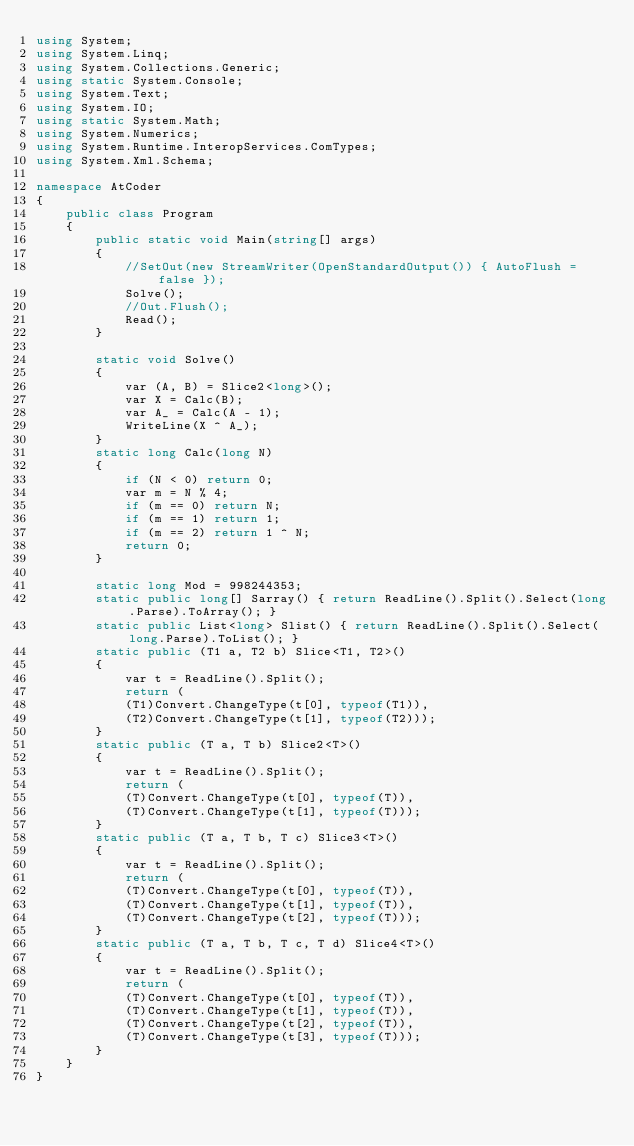<code> <loc_0><loc_0><loc_500><loc_500><_C#_>using System;
using System.Linq;
using System.Collections.Generic;
using static System.Console;
using System.Text;
using System.IO;
using static System.Math;
using System.Numerics;
using System.Runtime.InteropServices.ComTypes;
using System.Xml.Schema;

namespace AtCoder
{
    public class Program
    {
        public static void Main(string[] args)
        {
            //SetOut(new StreamWriter(OpenStandardOutput()) { AutoFlush = false });
            Solve();
            //Out.Flush();
            Read();
        }

        static void Solve()
        {
            var (A, B) = Slice2<long>();
            var X = Calc(B);
            var A_ = Calc(A - 1);
            WriteLine(X ^ A_);
        }
        static long Calc(long N)
        {
            if (N < 0) return 0;
            var m = N % 4;
            if (m == 0) return N;
            if (m == 1) return 1;
            if (m == 2) return 1 ^ N;
            return 0;
        }

        static long Mod = 998244353;
        static public long[] Sarray() { return ReadLine().Split().Select(long.Parse).ToArray(); }
        static public List<long> Slist() { return ReadLine().Split().Select(long.Parse).ToList(); }
        static public (T1 a, T2 b) Slice<T1, T2>()
        {
            var t = ReadLine().Split();
            return (
            (T1)Convert.ChangeType(t[0], typeof(T1)),
            (T2)Convert.ChangeType(t[1], typeof(T2)));
        }
        static public (T a, T b) Slice2<T>()
        {
            var t = ReadLine().Split();
            return (
            (T)Convert.ChangeType(t[0], typeof(T)),
            (T)Convert.ChangeType(t[1], typeof(T)));
        }
        static public (T a, T b, T c) Slice3<T>()
        {
            var t = ReadLine().Split();
            return (
            (T)Convert.ChangeType(t[0], typeof(T)),
            (T)Convert.ChangeType(t[1], typeof(T)),
            (T)Convert.ChangeType(t[2], typeof(T)));
        }
        static public (T a, T b, T c, T d) Slice4<T>()
        {
            var t = ReadLine().Split();
            return (
            (T)Convert.ChangeType(t[0], typeof(T)),
            (T)Convert.ChangeType(t[1], typeof(T)),
            (T)Convert.ChangeType(t[2], typeof(T)),
            (T)Convert.ChangeType(t[3], typeof(T)));
        }
    }
}</code> 